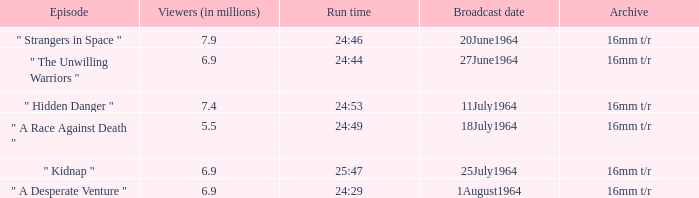Parse the table in full. {'header': ['Episode', 'Viewers (in millions)', 'Run time', 'Broadcast date', 'Archive'], 'rows': [['" Strangers in Space "', '7.9', '24:46', '20June1964', '16mm t/r'], ['" The Unwilling Warriors "', '6.9', '24:44', '27June1964', '16mm t/r'], ['" Hidden Danger "', '7.4', '24:53', '11July1964', '16mm t/r'], ['" A Race Against Death "', '5.5', '24:49', '18July1964', '16mm t/r'], ['" Kidnap "', '6.9', '25:47', '25July1964', '16mm t/r'], ['" A Desperate Venture "', '6.9', '24:29', '1August1964', '16mm t/r']]} How many viewers were there on 1august1964? 6.9. 